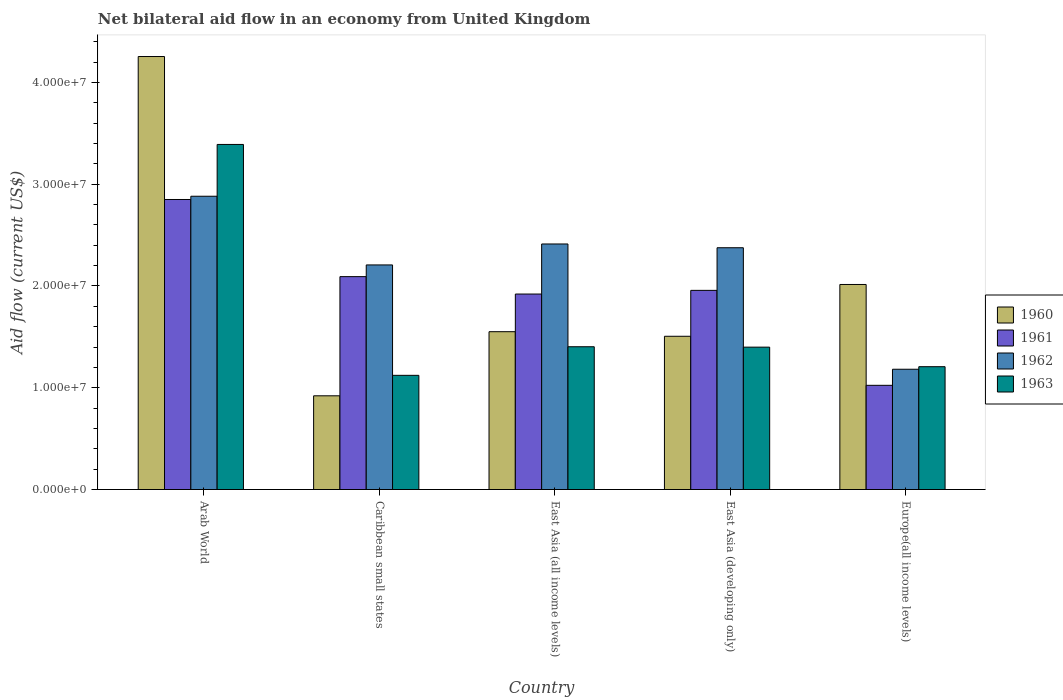How many different coloured bars are there?
Make the answer very short. 4. Are the number of bars on each tick of the X-axis equal?
Your answer should be very brief. Yes. How many bars are there on the 5th tick from the left?
Give a very brief answer. 4. How many bars are there on the 1st tick from the right?
Your answer should be compact. 4. What is the label of the 1st group of bars from the left?
Offer a very short reply. Arab World. What is the net bilateral aid flow in 1961 in Europe(all income levels)?
Offer a terse response. 1.02e+07. Across all countries, what is the maximum net bilateral aid flow in 1961?
Your response must be concise. 2.85e+07. Across all countries, what is the minimum net bilateral aid flow in 1962?
Provide a short and direct response. 1.18e+07. In which country was the net bilateral aid flow in 1962 maximum?
Keep it short and to the point. Arab World. In which country was the net bilateral aid flow in 1961 minimum?
Give a very brief answer. Europe(all income levels). What is the total net bilateral aid flow in 1962 in the graph?
Provide a short and direct response. 1.11e+08. What is the difference between the net bilateral aid flow in 1960 in Arab World and that in East Asia (developing only)?
Make the answer very short. 2.75e+07. What is the difference between the net bilateral aid flow in 1962 in Caribbean small states and the net bilateral aid flow in 1963 in Europe(all income levels)?
Your answer should be compact. 1.00e+07. What is the average net bilateral aid flow in 1961 per country?
Your answer should be compact. 1.97e+07. What is the difference between the net bilateral aid flow of/in 1962 and net bilateral aid flow of/in 1963 in Caribbean small states?
Your response must be concise. 1.08e+07. What is the ratio of the net bilateral aid flow in 1962 in Caribbean small states to that in East Asia (developing only)?
Your answer should be very brief. 0.93. What is the difference between the highest and the second highest net bilateral aid flow in 1962?
Your answer should be very brief. 5.06e+06. What is the difference between the highest and the lowest net bilateral aid flow in 1960?
Your response must be concise. 3.33e+07. In how many countries, is the net bilateral aid flow in 1960 greater than the average net bilateral aid flow in 1960 taken over all countries?
Your response must be concise. 1. Is the sum of the net bilateral aid flow in 1961 in Arab World and East Asia (developing only) greater than the maximum net bilateral aid flow in 1962 across all countries?
Your answer should be compact. Yes. What does the 3rd bar from the left in East Asia (all income levels) represents?
Your answer should be very brief. 1962. Are all the bars in the graph horizontal?
Offer a very short reply. No. Does the graph contain any zero values?
Your answer should be very brief. No. Does the graph contain grids?
Ensure brevity in your answer.  No. Where does the legend appear in the graph?
Make the answer very short. Center right. How are the legend labels stacked?
Your response must be concise. Vertical. What is the title of the graph?
Provide a succinct answer. Net bilateral aid flow in an economy from United Kingdom. What is the label or title of the X-axis?
Your answer should be very brief. Country. What is the Aid flow (current US$) of 1960 in Arab World?
Make the answer very short. 4.26e+07. What is the Aid flow (current US$) of 1961 in Arab World?
Offer a very short reply. 2.85e+07. What is the Aid flow (current US$) in 1962 in Arab World?
Keep it short and to the point. 2.88e+07. What is the Aid flow (current US$) in 1963 in Arab World?
Offer a terse response. 3.39e+07. What is the Aid flow (current US$) in 1960 in Caribbean small states?
Your answer should be compact. 9.21e+06. What is the Aid flow (current US$) of 1961 in Caribbean small states?
Keep it short and to the point. 2.09e+07. What is the Aid flow (current US$) of 1962 in Caribbean small states?
Give a very brief answer. 2.21e+07. What is the Aid flow (current US$) of 1963 in Caribbean small states?
Your answer should be very brief. 1.12e+07. What is the Aid flow (current US$) in 1960 in East Asia (all income levels)?
Offer a terse response. 1.55e+07. What is the Aid flow (current US$) in 1961 in East Asia (all income levels)?
Your response must be concise. 1.92e+07. What is the Aid flow (current US$) in 1962 in East Asia (all income levels)?
Your response must be concise. 2.41e+07. What is the Aid flow (current US$) of 1963 in East Asia (all income levels)?
Your answer should be very brief. 1.40e+07. What is the Aid flow (current US$) in 1960 in East Asia (developing only)?
Provide a short and direct response. 1.51e+07. What is the Aid flow (current US$) of 1961 in East Asia (developing only)?
Keep it short and to the point. 1.96e+07. What is the Aid flow (current US$) of 1962 in East Asia (developing only)?
Provide a short and direct response. 2.38e+07. What is the Aid flow (current US$) of 1963 in East Asia (developing only)?
Make the answer very short. 1.40e+07. What is the Aid flow (current US$) of 1960 in Europe(all income levels)?
Your response must be concise. 2.02e+07. What is the Aid flow (current US$) in 1961 in Europe(all income levels)?
Offer a terse response. 1.02e+07. What is the Aid flow (current US$) of 1962 in Europe(all income levels)?
Keep it short and to the point. 1.18e+07. What is the Aid flow (current US$) of 1963 in Europe(all income levels)?
Provide a short and direct response. 1.21e+07. Across all countries, what is the maximum Aid flow (current US$) in 1960?
Give a very brief answer. 4.26e+07. Across all countries, what is the maximum Aid flow (current US$) in 1961?
Provide a succinct answer. 2.85e+07. Across all countries, what is the maximum Aid flow (current US$) of 1962?
Give a very brief answer. 2.88e+07. Across all countries, what is the maximum Aid flow (current US$) in 1963?
Ensure brevity in your answer.  3.39e+07. Across all countries, what is the minimum Aid flow (current US$) in 1960?
Offer a very short reply. 9.21e+06. Across all countries, what is the minimum Aid flow (current US$) of 1961?
Provide a succinct answer. 1.02e+07. Across all countries, what is the minimum Aid flow (current US$) of 1962?
Your answer should be compact. 1.18e+07. Across all countries, what is the minimum Aid flow (current US$) of 1963?
Your answer should be very brief. 1.12e+07. What is the total Aid flow (current US$) in 1960 in the graph?
Offer a very short reply. 1.02e+08. What is the total Aid flow (current US$) in 1961 in the graph?
Ensure brevity in your answer.  9.84e+07. What is the total Aid flow (current US$) of 1962 in the graph?
Keep it short and to the point. 1.11e+08. What is the total Aid flow (current US$) in 1963 in the graph?
Make the answer very short. 8.52e+07. What is the difference between the Aid flow (current US$) of 1960 in Arab World and that in Caribbean small states?
Offer a very short reply. 3.33e+07. What is the difference between the Aid flow (current US$) of 1961 in Arab World and that in Caribbean small states?
Ensure brevity in your answer.  7.58e+06. What is the difference between the Aid flow (current US$) of 1962 in Arab World and that in Caribbean small states?
Your answer should be compact. 6.75e+06. What is the difference between the Aid flow (current US$) of 1963 in Arab World and that in Caribbean small states?
Offer a very short reply. 2.27e+07. What is the difference between the Aid flow (current US$) of 1960 in Arab World and that in East Asia (all income levels)?
Your response must be concise. 2.70e+07. What is the difference between the Aid flow (current US$) of 1961 in Arab World and that in East Asia (all income levels)?
Offer a very short reply. 9.29e+06. What is the difference between the Aid flow (current US$) of 1962 in Arab World and that in East Asia (all income levels)?
Provide a short and direct response. 4.69e+06. What is the difference between the Aid flow (current US$) in 1963 in Arab World and that in East Asia (all income levels)?
Give a very brief answer. 1.99e+07. What is the difference between the Aid flow (current US$) in 1960 in Arab World and that in East Asia (developing only)?
Offer a very short reply. 2.75e+07. What is the difference between the Aid flow (current US$) of 1961 in Arab World and that in East Asia (developing only)?
Offer a very short reply. 8.93e+06. What is the difference between the Aid flow (current US$) of 1962 in Arab World and that in East Asia (developing only)?
Make the answer very short. 5.06e+06. What is the difference between the Aid flow (current US$) in 1963 in Arab World and that in East Asia (developing only)?
Keep it short and to the point. 1.99e+07. What is the difference between the Aid flow (current US$) of 1960 in Arab World and that in Europe(all income levels)?
Your answer should be very brief. 2.24e+07. What is the difference between the Aid flow (current US$) of 1961 in Arab World and that in Europe(all income levels)?
Offer a terse response. 1.83e+07. What is the difference between the Aid flow (current US$) of 1962 in Arab World and that in Europe(all income levels)?
Offer a terse response. 1.70e+07. What is the difference between the Aid flow (current US$) of 1963 in Arab World and that in Europe(all income levels)?
Your answer should be very brief. 2.18e+07. What is the difference between the Aid flow (current US$) of 1960 in Caribbean small states and that in East Asia (all income levels)?
Keep it short and to the point. -6.30e+06. What is the difference between the Aid flow (current US$) of 1961 in Caribbean small states and that in East Asia (all income levels)?
Ensure brevity in your answer.  1.71e+06. What is the difference between the Aid flow (current US$) in 1962 in Caribbean small states and that in East Asia (all income levels)?
Ensure brevity in your answer.  -2.06e+06. What is the difference between the Aid flow (current US$) of 1963 in Caribbean small states and that in East Asia (all income levels)?
Your answer should be compact. -2.81e+06. What is the difference between the Aid flow (current US$) in 1960 in Caribbean small states and that in East Asia (developing only)?
Provide a succinct answer. -5.85e+06. What is the difference between the Aid flow (current US$) in 1961 in Caribbean small states and that in East Asia (developing only)?
Give a very brief answer. 1.35e+06. What is the difference between the Aid flow (current US$) of 1962 in Caribbean small states and that in East Asia (developing only)?
Offer a terse response. -1.69e+06. What is the difference between the Aid flow (current US$) in 1963 in Caribbean small states and that in East Asia (developing only)?
Your answer should be compact. -2.77e+06. What is the difference between the Aid flow (current US$) in 1960 in Caribbean small states and that in Europe(all income levels)?
Your answer should be very brief. -1.09e+07. What is the difference between the Aid flow (current US$) of 1961 in Caribbean small states and that in Europe(all income levels)?
Provide a short and direct response. 1.07e+07. What is the difference between the Aid flow (current US$) of 1962 in Caribbean small states and that in Europe(all income levels)?
Your response must be concise. 1.02e+07. What is the difference between the Aid flow (current US$) in 1963 in Caribbean small states and that in Europe(all income levels)?
Offer a very short reply. -8.50e+05. What is the difference between the Aid flow (current US$) in 1961 in East Asia (all income levels) and that in East Asia (developing only)?
Your answer should be compact. -3.60e+05. What is the difference between the Aid flow (current US$) in 1963 in East Asia (all income levels) and that in East Asia (developing only)?
Give a very brief answer. 4.00e+04. What is the difference between the Aid flow (current US$) in 1960 in East Asia (all income levels) and that in Europe(all income levels)?
Offer a very short reply. -4.64e+06. What is the difference between the Aid flow (current US$) in 1961 in East Asia (all income levels) and that in Europe(all income levels)?
Provide a succinct answer. 8.97e+06. What is the difference between the Aid flow (current US$) of 1962 in East Asia (all income levels) and that in Europe(all income levels)?
Offer a terse response. 1.23e+07. What is the difference between the Aid flow (current US$) in 1963 in East Asia (all income levels) and that in Europe(all income levels)?
Give a very brief answer. 1.96e+06. What is the difference between the Aid flow (current US$) in 1960 in East Asia (developing only) and that in Europe(all income levels)?
Your answer should be very brief. -5.09e+06. What is the difference between the Aid flow (current US$) of 1961 in East Asia (developing only) and that in Europe(all income levels)?
Provide a short and direct response. 9.33e+06. What is the difference between the Aid flow (current US$) of 1962 in East Asia (developing only) and that in Europe(all income levels)?
Make the answer very short. 1.19e+07. What is the difference between the Aid flow (current US$) in 1963 in East Asia (developing only) and that in Europe(all income levels)?
Offer a very short reply. 1.92e+06. What is the difference between the Aid flow (current US$) of 1960 in Arab World and the Aid flow (current US$) of 1961 in Caribbean small states?
Your answer should be compact. 2.16e+07. What is the difference between the Aid flow (current US$) in 1960 in Arab World and the Aid flow (current US$) in 1962 in Caribbean small states?
Provide a succinct answer. 2.05e+07. What is the difference between the Aid flow (current US$) in 1960 in Arab World and the Aid flow (current US$) in 1963 in Caribbean small states?
Ensure brevity in your answer.  3.13e+07. What is the difference between the Aid flow (current US$) of 1961 in Arab World and the Aid flow (current US$) of 1962 in Caribbean small states?
Make the answer very short. 6.43e+06. What is the difference between the Aid flow (current US$) of 1961 in Arab World and the Aid flow (current US$) of 1963 in Caribbean small states?
Offer a terse response. 1.73e+07. What is the difference between the Aid flow (current US$) in 1962 in Arab World and the Aid flow (current US$) in 1963 in Caribbean small states?
Keep it short and to the point. 1.76e+07. What is the difference between the Aid flow (current US$) in 1960 in Arab World and the Aid flow (current US$) in 1961 in East Asia (all income levels)?
Offer a terse response. 2.33e+07. What is the difference between the Aid flow (current US$) of 1960 in Arab World and the Aid flow (current US$) of 1962 in East Asia (all income levels)?
Your answer should be compact. 1.84e+07. What is the difference between the Aid flow (current US$) of 1960 in Arab World and the Aid flow (current US$) of 1963 in East Asia (all income levels)?
Provide a succinct answer. 2.85e+07. What is the difference between the Aid flow (current US$) of 1961 in Arab World and the Aid flow (current US$) of 1962 in East Asia (all income levels)?
Provide a short and direct response. 4.37e+06. What is the difference between the Aid flow (current US$) in 1961 in Arab World and the Aid flow (current US$) in 1963 in East Asia (all income levels)?
Your answer should be very brief. 1.45e+07. What is the difference between the Aid flow (current US$) in 1962 in Arab World and the Aid flow (current US$) in 1963 in East Asia (all income levels)?
Your answer should be compact. 1.48e+07. What is the difference between the Aid flow (current US$) in 1960 in Arab World and the Aid flow (current US$) in 1961 in East Asia (developing only)?
Your response must be concise. 2.30e+07. What is the difference between the Aid flow (current US$) in 1960 in Arab World and the Aid flow (current US$) in 1962 in East Asia (developing only)?
Offer a terse response. 1.88e+07. What is the difference between the Aid flow (current US$) of 1960 in Arab World and the Aid flow (current US$) of 1963 in East Asia (developing only)?
Keep it short and to the point. 2.86e+07. What is the difference between the Aid flow (current US$) of 1961 in Arab World and the Aid flow (current US$) of 1962 in East Asia (developing only)?
Keep it short and to the point. 4.74e+06. What is the difference between the Aid flow (current US$) of 1961 in Arab World and the Aid flow (current US$) of 1963 in East Asia (developing only)?
Your response must be concise. 1.45e+07. What is the difference between the Aid flow (current US$) of 1962 in Arab World and the Aid flow (current US$) of 1963 in East Asia (developing only)?
Provide a short and direct response. 1.48e+07. What is the difference between the Aid flow (current US$) in 1960 in Arab World and the Aid flow (current US$) in 1961 in Europe(all income levels)?
Your response must be concise. 3.23e+07. What is the difference between the Aid flow (current US$) of 1960 in Arab World and the Aid flow (current US$) of 1962 in Europe(all income levels)?
Ensure brevity in your answer.  3.07e+07. What is the difference between the Aid flow (current US$) in 1960 in Arab World and the Aid flow (current US$) in 1963 in Europe(all income levels)?
Provide a short and direct response. 3.05e+07. What is the difference between the Aid flow (current US$) in 1961 in Arab World and the Aid flow (current US$) in 1962 in Europe(all income levels)?
Offer a terse response. 1.67e+07. What is the difference between the Aid flow (current US$) in 1961 in Arab World and the Aid flow (current US$) in 1963 in Europe(all income levels)?
Give a very brief answer. 1.64e+07. What is the difference between the Aid flow (current US$) in 1962 in Arab World and the Aid flow (current US$) in 1963 in Europe(all income levels)?
Ensure brevity in your answer.  1.68e+07. What is the difference between the Aid flow (current US$) in 1960 in Caribbean small states and the Aid flow (current US$) in 1961 in East Asia (all income levels)?
Keep it short and to the point. -1.00e+07. What is the difference between the Aid flow (current US$) in 1960 in Caribbean small states and the Aid flow (current US$) in 1962 in East Asia (all income levels)?
Your response must be concise. -1.49e+07. What is the difference between the Aid flow (current US$) of 1960 in Caribbean small states and the Aid flow (current US$) of 1963 in East Asia (all income levels)?
Provide a succinct answer. -4.82e+06. What is the difference between the Aid flow (current US$) of 1961 in Caribbean small states and the Aid flow (current US$) of 1962 in East Asia (all income levels)?
Offer a terse response. -3.21e+06. What is the difference between the Aid flow (current US$) of 1961 in Caribbean small states and the Aid flow (current US$) of 1963 in East Asia (all income levels)?
Give a very brief answer. 6.89e+06. What is the difference between the Aid flow (current US$) in 1962 in Caribbean small states and the Aid flow (current US$) in 1963 in East Asia (all income levels)?
Provide a short and direct response. 8.04e+06. What is the difference between the Aid flow (current US$) in 1960 in Caribbean small states and the Aid flow (current US$) in 1961 in East Asia (developing only)?
Make the answer very short. -1.04e+07. What is the difference between the Aid flow (current US$) in 1960 in Caribbean small states and the Aid flow (current US$) in 1962 in East Asia (developing only)?
Make the answer very short. -1.46e+07. What is the difference between the Aid flow (current US$) of 1960 in Caribbean small states and the Aid flow (current US$) of 1963 in East Asia (developing only)?
Your answer should be very brief. -4.78e+06. What is the difference between the Aid flow (current US$) in 1961 in Caribbean small states and the Aid flow (current US$) in 1962 in East Asia (developing only)?
Keep it short and to the point. -2.84e+06. What is the difference between the Aid flow (current US$) of 1961 in Caribbean small states and the Aid flow (current US$) of 1963 in East Asia (developing only)?
Offer a very short reply. 6.93e+06. What is the difference between the Aid flow (current US$) of 1962 in Caribbean small states and the Aid flow (current US$) of 1963 in East Asia (developing only)?
Your answer should be very brief. 8.08e+06. What is the difference between the Aid flow (current US$) of 1960 in Caribbean small states and the Aid flow (current US$) of 1961 in Europe(all income levels)?
Ensure brevity in your answer.  -1.03e+06. What is the difference between the Aid flow (current US$) of 1960 in Caribbean small states and the Aid flow (current US$) of 1962 in Europe(all income levels)?
Ensure brevity in your answer.  -2.61e+06. What is the difference between the Aid flow (current US$) of 1960 in Caribbean small states and the Aid flow (current US$) of 1963 in Europe(all income levels)?
Your response must be concise. -2.86e+06. What is the difference between the Aid flow (current US$) of 1961 in Caribbean small states and the Aid flow (current US$) of 1962 in Europe(all income levels)?
Ensure brevity in your answer.  9.10e+06. What is the difference between the Aid flow (current US$) of 1961 in Caribbean small states and the Aid flow (current US$) of 1963 in Europe(all income levels)?
Your answer should be very brief. 8.85e+06. What is the difference between the Aid flow (current US$) of 1960 in East Asia (all income levels) and the Aid flow (current US$) of 1961 in East Asia (developing only)?
Your answer should be very brief. -4.06e+06. What is the difference between the Aid flow (current US$) in 1960 in East Asia (all income levels) and the Aid flow (current US$) in 1962 in East Asia (developing only)?
Offer a very short reply. -8.25e+06. What is the difference between the Aid flow (current US$) of 1960 in East Asia (all income levels) and the Aid flow (current US$) of 1963 in East Asia (developing only)?
Provide a succinct answer. 1.52e+06. What is the difference between the Aid flow (current US$) in 1961 in East Asia (all income levels) and the Aid flow (current US$) in 1962 in East Asia (developing only)?
Your response must be concise. -4.55e+06. What is the difference between the Aid flow (current US$) in 1961 in East Asia (all income levels) and the Aid flow (current US$) in 1963 in East Asia (developing only)?
Provide a succinct answer. 5.22e+06. What is the difference between the Aid flow (current US$) of 1962 in East Asia (all income levels) and the Aid flow (current US$) of 1963 in East Asia (developing only)?
Ensure brevity in your answer.  1.01e+07. What is the difference between the Aid flow (current US$) in 1960 in East Asia (all income levels) and the Aid flow (current US$) in 1961 in Europe(all income levels)?
Give a very brief answer. 5.27e+06. What is the difference between the Aid flow (current US$) of 1960 in East Asia (all income levels) and the Aid flow (current US$) of 1962 in Europe(all income levels)?
Your response must be concise. 3.69e+06. What is the difference between the Aid flow (current US$) in 1960 in East Asia (all income levels) and the Aid flow (current US$) in 1963 in Europe(all income levels)?
Offer a very short reply. 3.44e+06. What is the difference between the Aid flow (current US$) of 1961 in East Asia (all income levels) and the Aid flow (current US$) of 1962 in Europe(all income levels)?
Provide a short and direct response. 7.39e+06. What is the difference between the Aid flow (current US$) of 1961 in East Asia (all income levels) and the Aid flow (current US$) of 1963 in Europe(all income levels)?
Make the answer very short. 7.14e+06. What is the difference between the Aid flow (current US$) of 1962 in East Asia (all income levels) and the Aid flow (current US$) of 1963 in Europe(all income levels)?
Provide a short and direct response. 1.21e+07. What is the difference between the Aid flow (current US$) in 1960 in East Asia (developing only) and the Aid flow (current US$) in 1961 in Europe(all income levels)?
Ensure brevity in your answer.  4.82e+06. What is the difference between the Aid flow (current US$) in 1960 in East Asia (developing only) and the Aid flow (current US$) in 1962 in Europe(all income levels)?
Provide a succinct answer. 3.24e+06. What is the difference between the Aid flow (current US$) in 1960 in East Asia (developing only) and the Aid flow (current US$) in 1963 in Europe(all income levels)?
Make the answer very short. 2.99e+06. What is the difference between the Aid flow (current US$) in 1961 in East Asia (developing only) and the Aid flow (current US$) in 1962 in Europe(all income levels)?
Ensure brevity in your answer.  7.75e+06. What is the difference between the Aid flow (current US$) in 1961 in East Asia (developing only) and the Aid flow (current US$) in 1963 in Europe(all income levels)?
Keep it short and to the point. 7.50e+06. What is the difference between the Aid flow (current US$) in 1962 in East Asia (developing only) and the Aid flow (current US$) in 1963 in Europe(all income levels)?
Offer a very short reply. 1.17e+07. What is the average Aid flow (current US$) of 1960 per country?
Your answer should be compact. 2.05e+07. What is the average Aid flow (current US$) of 1961 per country?
Your answer should be very brief. 1.97e+07. What is the average Aid flow (current US$) of 1962 per country?
Your answer should be compact. 2.21e+07. What is the average Aid flow (current US$) of 1963 per country?
Provide a succinct answer. 1.70e+07. What is the difference between the Aid flow (current US$) of 1960 and Aid flow (current US$) of 1961 in Arab World?
Your answer should be very brief. 1.40e+07. What is the difference between the Aid flow (current US$) in 1960 and Aid flow (current US$) in 1962 in Arab World?
Provide a short and direct response. 1.37e+07. What is the difference between the Aid flow (current US$) in 1960 and Aid flow (current US$) in 1963 in Arab World?
Ensure brevity in your answer.  8.64e+06. What is the difference between the Aid flow (current US$) in 1961 and Aid flow (current US$) in 1962 in Arab World?
Give a very brief answer. -3.20e+05. What is the difference between the Aid flow (current US$) of 1961 and Aid flow (current US$) of 1963 in Arab World?
Your response must be concise. -5.41e+06. What is the difference between the Aid flow (current US$) of 1962 and Aid flow (current US$) of 1963 in Arab World?
Keep it short and to the point. -5.09e+06. What is the difference between the Aid flow (current US$) in 1960 and Aid flow (current US$) in 1961 in Caribbean small states?
Keep it short and to the point. -1.17e+07. What is the difference between the Aid flow (current US$) of 1960 and Aid flow (current US$) of 1962 in Caribbean small states?
Make the answer very short. -1.29e+07. What is the difference between the Aid flow (current US$) in 1960 and Aid flow (current US$) in 1963 in Caribbean small states?
Your answer should be very brief. -2.01e+06. What is the difference between the Aid flow (current US$) of 1961 and Aid flow (current US$) of 1962 in Caribbean small states?
Provide a succinct answer. -1.15e+06. What is the difference between the Aid flow (current US$) of 1961 and Aid flow (current US$) of 1963 in Caribbean small states?
Offer a terse response. 9.70e+06. What is the difference between the Aid flow (current US$) of 1962 and Aid flow (current US$) of 1963 in Caribbean small states?
Your response must be concise. 1.08e+07. What is the difference between the Aid flow (current US$) in 1960 and Aid flow (current US$) in 1961 in East Asia (all income levels)?
Provide a short and direct response. -3.70e+06. What is the difference between the Aid flow (current US$) in 1960 and Aid flow (current US$) in 1962 in East Asia (all income levels)?
Offer a terse response. -8.62e+06. What is the difference between the Aid flow (current US$) of 1960 and Aid flow (current US$) of 1963 in East Asia (all income levels)?
Offer a very short reply. 1.48e+06. What is the difference between the Aid flow (current US$) of 1961 and Aid flow (current US$) of 1962 in East Asia (all income levels)?
Ensure brevity in your answer.  -4.92e+06. What is the difference between the Aid flow (current US$) of 1961 and Aid flow (current US$) of 1963 in East Asia (all income levels)?
Provide a succinct answer. 5.18e+06. What is the difference between the Aid flow (current US$) of 1962 and Aid flow (current US$) of 1963 in East Asia (all income levels)?
Your response must be concise. 1.01e+07. What is the difference between the Aid flow (current US$) in 1960 and Aid flow (current US$) in 1961 in East Asia (developing only)?
Your answer should be very brief. -4.51e+06. What is the difference between the Aid flow (current US$) in 1960 and Aid flow (current US$) in 1962 in East Asia (developing only)?
Provide a short and direct response. -8.70e+06. What is the difference between the Aid flow (current US$) of 1960 and Aid flow (current US$) of 1963 in East Asia (developing only)?
Give a very brief answer. 1.07e+06. What is the difference between the Aid flow (current US$) in 1961 and Aid flow (current US$) in 1962 in East Asia (developing only)?
Provide a succinct answer. -4.19e+06. What is the difference between the Aid flow (current US$) in 1961 and Aid flow (current US$) in 1963 in East Asia (developing only)?
Your response must be concise. 5.58e+06. What is the difference between the Aid flow (current US$) in 1962 and Aid flow (current US$) in 1963 in East Asia (developing only)?
Offer a very short reply. 9.77e+06. What is the difference between the Aid flow (current US$) in 1960 and Aid flow (current US$) in 1961 in Europe(all income levels)?
Your answer should be very brief. 9.91e+06. What is the difference between the Aid flow (current US$) of 1960 and Aid flow (current US$) of 1962 in Europe(all income levels)?
Your response must be concise. 8.33e+06. What is the difference between the Aid flow (current US$) in 1960 and Aid flow (current US$) in 1963 in Europe(all income levels)?
Your answer should be very brief. 8.08e+06. What is the difference between the Aid flow (current US$) in 1961 and Aid flow (current US$) in 1962 in Europe(all income levels)?
Give a very brief answer. -1.58e+06. What is the difference between the Aid flow (current US$) in 1961 and Aid flow (current US$) in 1963 in Europe(all income levels)?
Offer a terse response. -1.83e+06. What is the ratio of the Aid flow (current US$) in 1960 in Arab World to that in Caribbean small states?
Make the answer very short. 4.62. What is the ratio of the Aid flow (current US$) of 1961 in Arab World to that in Caribbean small states?
Ensure brevity in your answer.  1.36. What is the ratio of the Aid flow (current US$) of 1962 in Arab World to that in Caribbean small states?
Keep it short and to the point. 1.31. What is the ratio of the Aid flow (current US$) of 1963 in Arab World to that in Caribbean small states?
Offer a terse response. 3.02. What is the ratio of the Aid flow (current US$) of 1960 in Arab World to that in East Asia (all income levels)?
Provide a succinct answer. 2.74. What is the ratio of the Aid flow (current US$) of 1961 in Arab World to that in East Asia (all income levels)?
Give a very brief answer. 1.48. What is the ratio of the Aid flow (current US$) of 1962 in Arab World to that in East Asia (all income levels)?
Offer a terse response. 1.19. What is the ratio of the Aid flow (current US$) in 1963 in Arab World to that in East Asia (all income levels)?
Offer a terse response. 2.42. What is the ratio of the Aid flow (current US$) of 1960 in Arab World to that in East Asia (developing only)?
Make the answer very short. 2.83. What is the ratio of the Aid flow (current US$) in 1961 in Arab World to that in East Asia (developing only)?
Your answer should be compact. 1.46. What is the ratio of the Aid flow (current US$) in 1962 in Arab World to that in East Asia (developing only)?
Your answer should be very brief. 1.21. What is the ratio of the Aid flow (current US$) in 1963 in Arab World to that in East Asia (developing only)?
Your response must be concise. 2.42. What is the ratio of the Aid flow (current US$) of 1960 in Arab World to that in Europe(all income levels)?
Make the answer very short. 2.11. What is the ratio of the Aid flow (current US$) of 1961 in Arab World to that in Europe(all income levels)?
Your answer should be very brief. 2.78. What is the ratio of the Aid flow (current US$) of 1962 in Arab World to that in Europe(all income levels)?
Your answer should be compact. 2.44. What is the ratio of the Aid flow (current US$) in 1963 in Arab World to that in Europe(all income levels)?
Provide a succinct answer. 2.81. What is the ratio of the Aid flow (current US$) in 1960 in Caribbean small states to that in East Asia (all income levels)?
Provide a short and direct response. 0.59. What is the ratio of the Aid flow (current US$) of 1961 in Caribbean small states to that in East Asia (all income levels)?
Make the answer very short. 1.09. What is the ratio of the Aid flow (current US$) in 1962 in Caribbean small states to that in East Asia (all income levels)?
Give a very brief answer. 0.91. What is the ratio of the Aid flow (current US$) of 1963 in Caribbean small states to that in East Asia (all income levels)?
Provide a short and direct response. 0.8. What is the ratio of the Aid flow (current US$) of 1960 in Caribbean small states to that in East Asia (developing only)?
Your response must be concise. 0.61. What is the ratio of the Aid flow (current US$) in 1961 in Caribbean small states to that in East Asia (developing only)?
Your answer should be compact. 1.07. What is the ratio of the Aid flow (current US$) in 1962 in Caribbean small states to that in East Asia (developing only)?
Ensure brevity in your answer.  0.93. What is the ratio of the Aid flow (current US$) in 1963 in Caribbean small states to that in East Asia (developing only)?
Make the answer very short. 0.8. What is the ratio of the Aid flow (current US$) in 1960 in Caribbean small states to that in Europe(all income levels)?
Your response must be concise. 0.46. What is the ratio of the Aid flow (current US$) in 1961 in Caribbean small states to that in Europe(all income levels)?
Give a very brief answer. 2.04. What is the ratio of the Aid flow (current US$) of 1962 in Caribbean small states to that in Europe(all income levels)?
Offer a very short reply. 1.87. What is the ratio of the Aid flow (current US$) in 1963 in Caribbean small states to that in Europe(all income levels)?
Offer a terse response. 0.93. What is the ratio of the Aid flow (current US$) in 1960 in East Asia (all income levels) to that in East Asia (developing only)?
Your response must be concise. 1.03. What is the ratio of the Aid flow (current US$) of 1961 in East Asia (all income levels) to that in East Asia (developing only)?
Make the answer very short. 0.98. What is the ratio of the Aid flow (current US$) of 1962 in East Asia (all income levels) to that in East Asia (developing only)?
Keep it short and to the point. 1.02. What is the ratio of the Aid flow (current US$) of 1960 in East Asia (all income levels) to that in Europe(all income levels)?
Provide a succinct answer. 0.77. What is the ratio of the Aid flow (current US$) of 1961 in East Asia (all income levels) to that in Europe(all income levels)?
Your response must be concise. 1.88. What is the ratio of the Aid flow (current US$) of 1962 in East Asia (all income levels) to that in Europe(all income levels)?
Your answer should be very brief. 2.04. What is the ratio of the Aid flow (current US$) in 1963 in East Asia (all income levels) to that in Europe(all income levels)?
Give a very brief answer. 1.16. What is the ratio of the Aid flow (current US$) in 1960 in East Asia (developing only) to that in Europe(all income levels)?
Give a very brief answer. 0.75. What is the ratio of the Aid flow (current US$) in 1961 in East Asia (developing only) to that in Europe(all income levels)?
Give a very brief answer. 1.91. What is the ratio of the Aid flow (current US$) in 1962 in East Asia (developing only) to that in Europe(all income levels)?
Your answer should be very brief. 2.01. What is the ratio of the Aid flow (current US$) of 1963 in East Asia (developing only) to that in Europe(all income levels)?
Your answer should be very brief. 1.16. What is the difference between the highest and the second highest Aid flow (current US$) of 1960?
Keep it short and to the point. 2.24e+07. What is the difference between the highest and the second highest Aid flow (current US$) of 1961?
Make the answer very short. 7.58e+06. What is the difference between the highest and the second highest Aid flow (current US$) of 1962?
Give a very brief answer. 4.69e+06. What is the difference between the highest and the second highest Aid flow (current US$) in 1963?
Ensure brevity in your answer.  1.99e+07. What is the difference between the highest and the lowest Aid flow (current US$) of 1960?
Provide a succinct answer. 3.33e+07. What is the difference between the highest and the lowest Aid flow (current US$) of 1961?
Make the answer very short. 1.83e+07. What is the difference between the highest and the lowest Aid flow (current US$) of 1962?
Ensure brevity in your answer.  1.70e+07. What is the difference between the highest and the lowest Aid flow (current US$) in 1963?
Provide a short and direct response. 2.27e+07. 